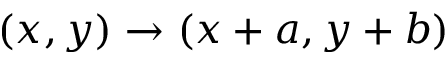<formula> <loc_0><loc_0><loc_500><loc_500>( x , y ) \rightarrow ( x + a , y + b )</formula> 